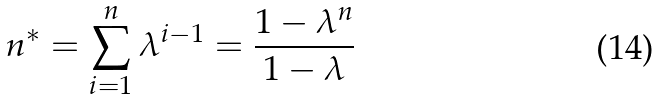<formula> <loc_0><loc_0><loc_500><loc_500>n ^ { * } = \sum _ { i = 1 } ^ { n } \lambda ^ { i - 1 } = \frac { 1 - \lambda ^ { n } } { 1 - \lambda }</formula> 